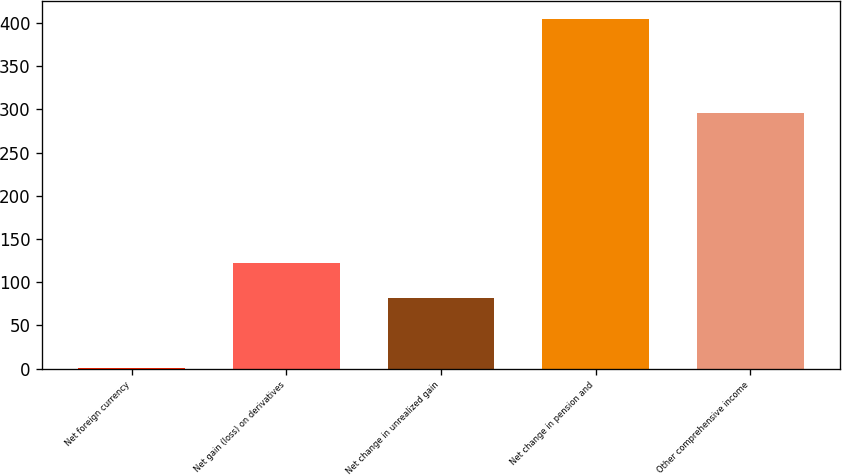<chart> <loc_0><loc_0><loc_500><loc_500><bar_chart><fcel>Net foreign currency<fcel>Net gain (loss) on derivatives<fcel>Net change in unrealized gain<fcel>Net change in pension and<fcel>Other comprehensive income<nl><fcel>1<fcel>122.2<fcel>81.8<fcel>405<fcel>296<nl></chart> 